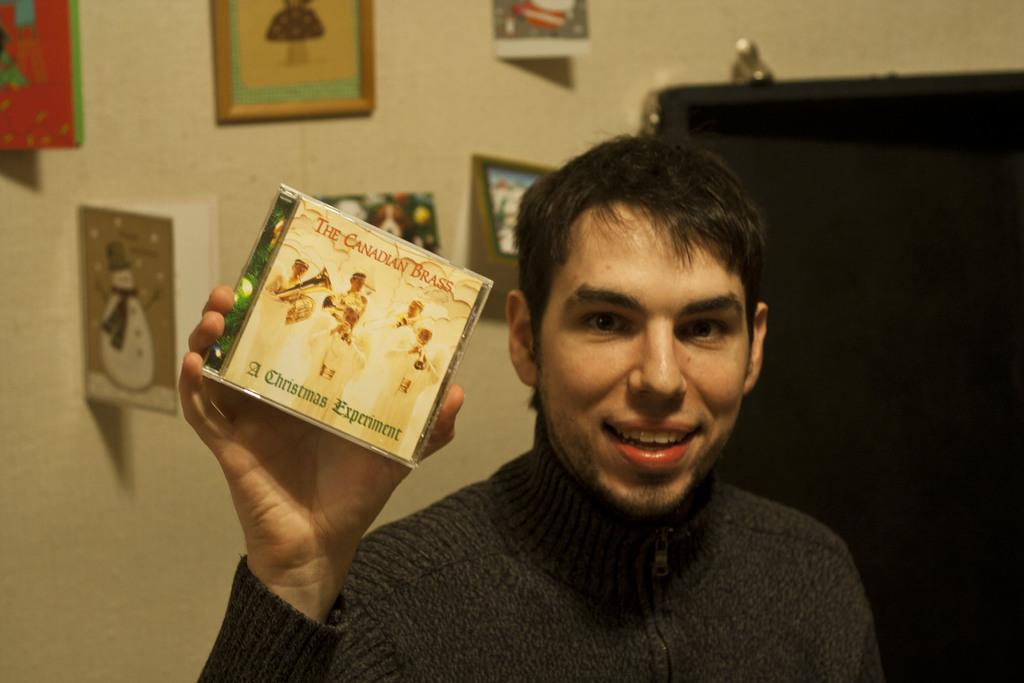What can be seen in the image related to a person? There is a person in the image. What is the person holding in the image? The person is holding an object with text on it. What type of decorative items are visible in the image? There are frames visible in the image. What can be seen hanging on the wall in the image? There are cards hanging on the wall. What architectural feature is present in the image? There is a door in the image. What type of furniture is being used by the servant in the image? There is no servant present in the image, and no furniture is visible. 